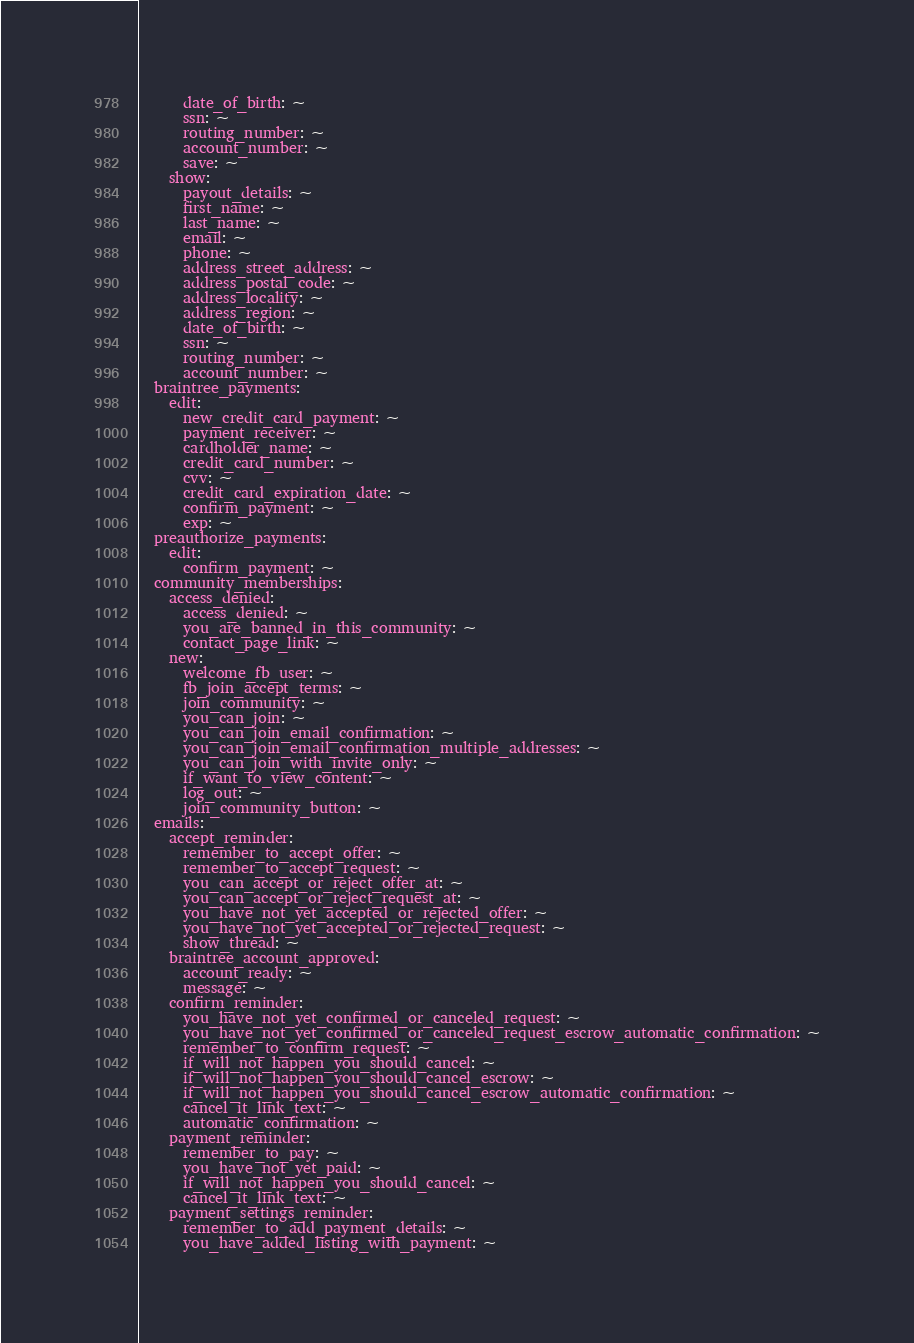Convert code to text. <code><loc_0><loc_0><loc_500><loc_500><_YAML_>      date_of_birth: ~
      ssn: ~
      routing_number: ~
      account_number: ~
      save: ~
    show:
      payout_details: ~
      first_name: ~
      last_name: ~
      email: ~
      phone: ~
      address_street_address: ~
      address_postal_code: ~
      address_locality: ~
      address_region: ~
      date_of_birth: ~
      ssn: ~
      routing_number: ~
      account_number: ~
  braintree_payments:
    edit:
      new_credit_card_payment: ~
      payment_receiver: ~
      cardholder_name: ~
      credit_card_number: ~
      cvv: ~
      credit_card_expiration_date: ~
      confirm_payment: ~
      exp: ~
  preauthorize_payments:
    edit:
      confirm_payment: ~
  community_memberships:
    access_denied:
      access_denied: ~
      you_are_banned_in_this_community: ~
      contact_page_link: ~
    new:
      welcome_fb_user: ~
      fb_join_accept_terms: ~
      join_community: ~
      you_can_join: ~
      you_can_join_email_confirmation: ~
      you_can_join_email_confirmation_multiple_addresses: ~
      you_can_join_with_invite_only: ~
      if_want_to_view_content: ~
      log_out: ~
      join_community_button: ~
  emails:
    accept_reminder:
      remember_to_accept_offer: ~
      remember_to_accept_request: ~
      you_can_accept_or_reject_offer_at: ~
      you_can_accept_or_reject_request_at: ~
      you_have_not_yet_accepted_or_rejected_offer: ~
      you_have_not_yet_accepted_or_rejected_request: ~
      show_thread: ~
    braintree_account_approved:
      account_ready: ~
      message: ~
    confirm_reminder:
      you_have_not_yet_confirmed_or_canceled_request: ~
      you_have_not_yet_confirmed_or_canceled_request_escrow_automatic_confirmation: ~
      remember_to_confirm_request: ~
      if_will_not_happen_you_should_cancel: ~
      if_will_not_happen_you_should_cancel_escrow: ~
      if_will_not_happen_you_should_cancel_escrow_automatic_confirmation: ~
      cancel_it_link_text: ~
      automatic_confirmation: ~
    payment_reminder:
      remember_to_pay: ~
      you_have_not_yet_paid: ~
      if_will_not_happen_you_should_cancel: ~
      cancel_it_link_text: ~
    payment_settings_reminder:
      remember_to_add_payment_details: ~
      you_have_added_listing_with_payment: ~</code> 